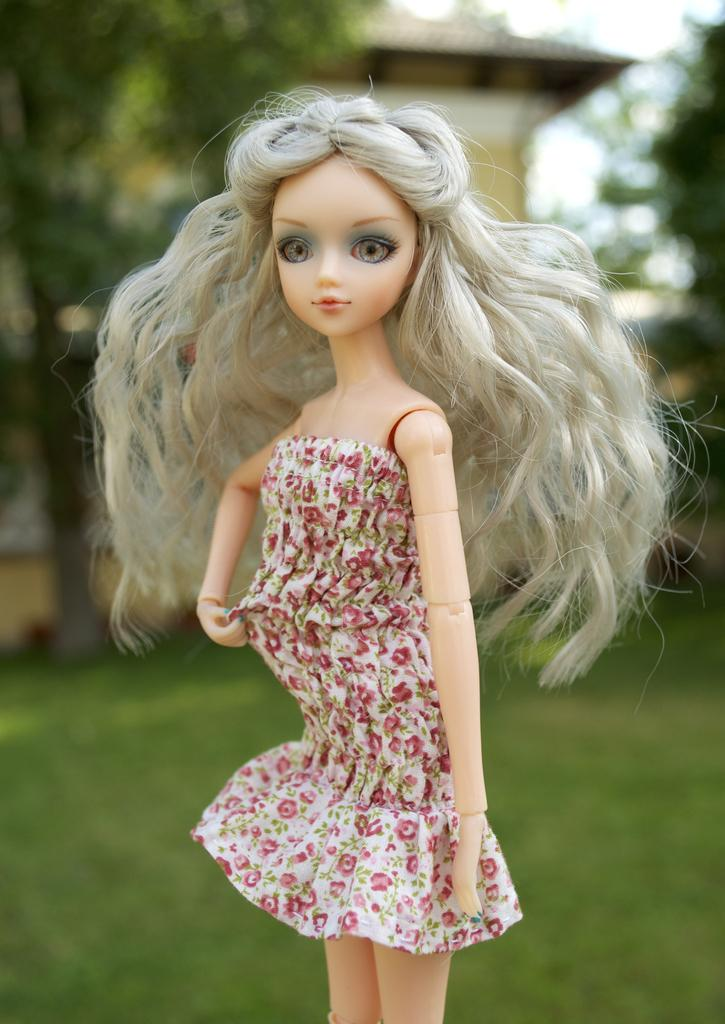What is the main subject in the front of the image? There is a doll in the front of the image. What type of natural environment is visible in the background of the image? There is grass, trees, and a house in the background of the image. How many eggs are visible in the image? There are no eggs present in the image. Who is the visitor in the image? There is no visitor present in the image. 